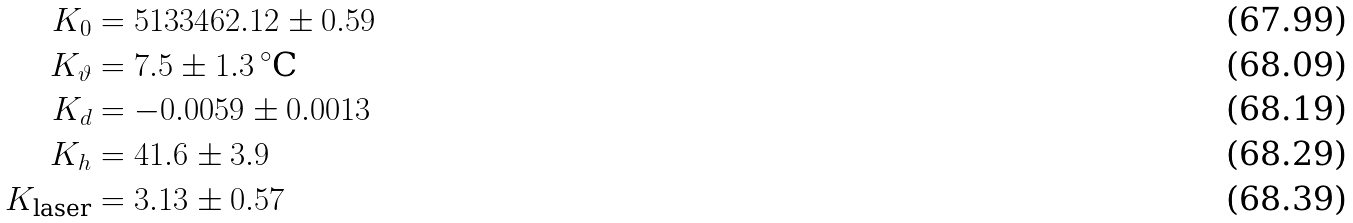Convert formula to latex. <formula><loc_0><loc_0><loc_500><loc_500>K _ { 0 } & = 5 1 3 3 4 6 2 . 1 2 \pm 0 . 5 9 \\ K _ { \vartheta } & = 7 . 5 \pm 1 . 3 \, ^ { \circ } \text {C} \\ K _ { d } & = - 0 . 0 0 5 9 \pm 0 . 0 0 1 3 \\ K _ { h } & = 4 1 . 6 \pm 3 . 9 \\ K _ { \text {laser} } & = 3 . 1 3 \pm 0 . 5 7</formula> 